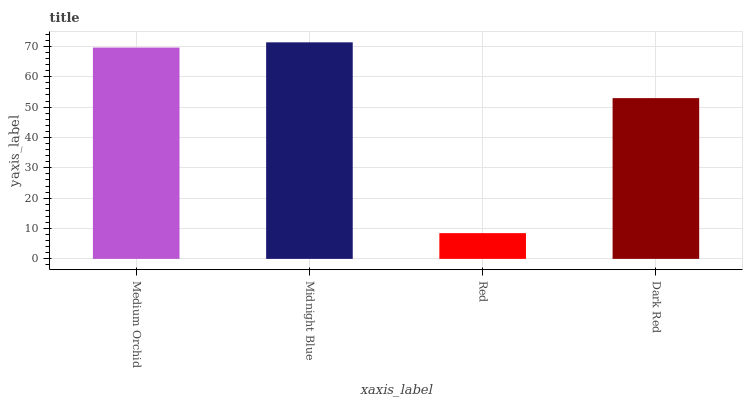Is Red the minimum?
Answer yes or no. Yes. Is Midnight Blue the maximum?
Answer yes or no. Yes. Is Midnight Blue the minimum?
Answer yes or no. No. Is Red the maximum?
Answer yes or no. No. Is Midnight Blue greater than Red?
Answer yes or no. Yes. Is Red less than Midnight Blue?
Answer yes or no. Yes. Is Red greater than Midnight Blue?
Answer yes or no. No. Is Midnight Blue less than Red?
Answer yes or no. No. Is Medium Orchid the high median?
Answer yes or no. Yes. Is Dark Red the low median?
Answer yes or no. Yes. Is Midnight Blue the high median?
Answer yes or no. No. Is Red the low median?
Answer yes or no. No. 